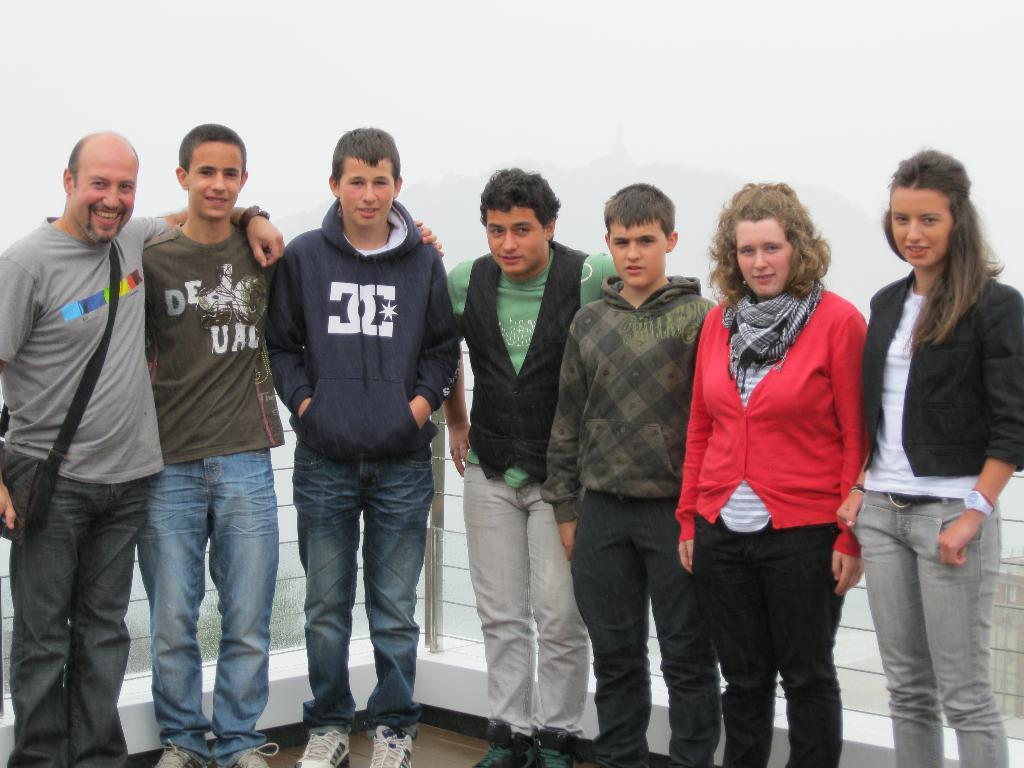How many people are in the image? There are persons in the image. What are the people wearing? The persons are wearing different color dresses. What is the facial expression of the people in the image? The persons are smiling. What position are the people in? The persons are standing. What is in the background of the image? The sky is visible in the background of the image. Is there any structure or object separating the people from the background? Yes, there is a fence in the image. How many territories can be seen in the image? There is no reference to territories in the image; it features people standing near a fence with a visible sky in the background. What type of window is visible in the image? There is no window present in the image. 